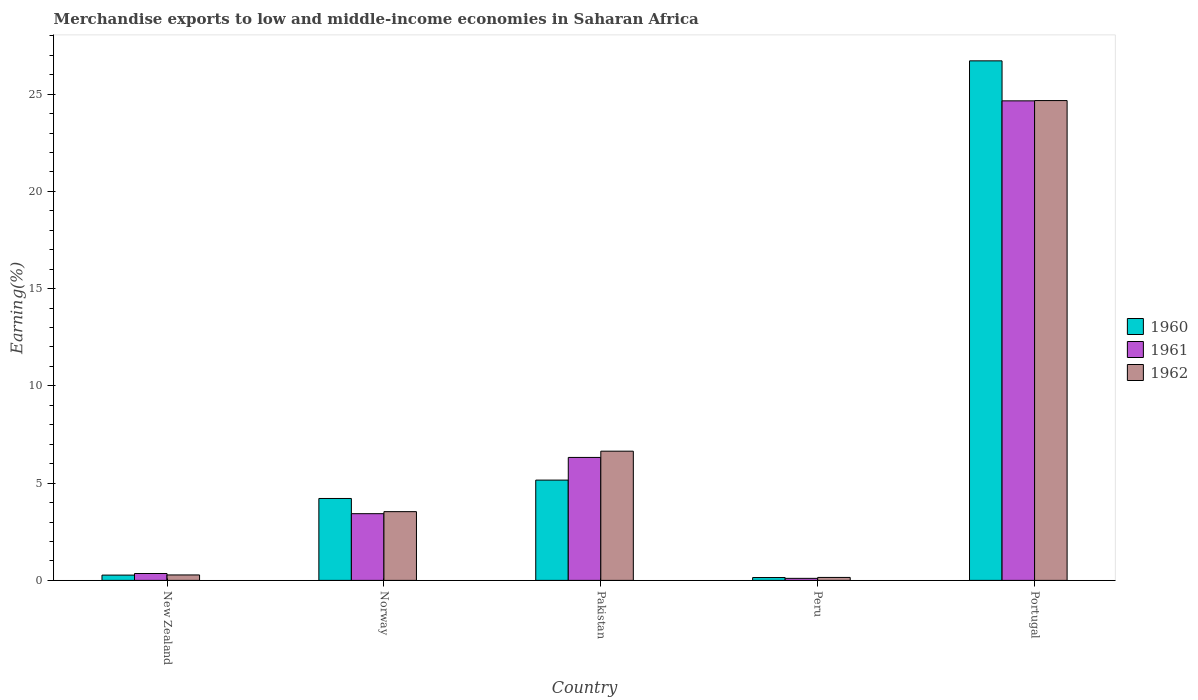Are the number of bars per tick equal to the number of legend labels?
Keep it short and to the point. Yes. Are the number of bars on each tick of the X-axis equal?
Your answer should be compact. Yes. How many bars are there on the 1st tick from the left?
Offer a very short reply. 3. How many bars are there on the 4th tick from the right?
Ensure brevity in your answer.  3. What is the percentage of amount earned from merchandise exports in 1962 in New Zealand?
Make the answer very short. 0.28. Across all countries, what is the maximum percentage of amount earned from merchandise exports in 1961?
Offer a very short reply. 24.65. Across all countries, what is the minimum percentage of amount earned from merchandise exports in 1960?
Your answer should be very brief. 0.15. In which country was the percentage of amount earned from merchandise exports in 1960 minimum?
Offer a terse response. Peru. What is the total percentage of amount earned from merchandise exports in 1961 in the graph?
Offer a very short reply. 34.86. What is the difference between the percentage of amount earned from merchandise exports in 1962 in New Zealand and that in Portugal?
Make the answer very short. -24.39. What is the difference between the percentage of amount earned from merchandise exports in 1961 in Portugal and the percentage of amount earned from merchandise exports in 1962 in New Zealand?
Provide a short and direct response. 24.37. What is the average percentage of amount earned from merchandise exports in 1960 per country?
Your answer should be compact. 7.3. What is the difference between the percentage of amount earned from merchandise exports of/in 1961 and percentage of amount earned from merchandise exports of/in 1960 in New Zealand?
Offer a very short reply. 0.08. In how many countries, is the percentage of amount earned from merchandise exports in 1962 greater than 6 %?
Keep it short and to the point. 2. What is the ratio of the percentage of amount earned from merchandise exports in 1962 in New Zealand to that in Peru?
Your answer should be compact. 1.84. Is the percentage of amount earned from merchandise exports in 1960 in Pakistan less than that in Portugal?
Your answer should be compact. Yes. What is the difference between the highest and the second highest percentage of amount earned from merchandise exports in 1960?
Make the answer very short. 22.5. What is the difference between the highest and the lowest percentage of amount earned from merchandise exports in 1960?
Offer a terse response. 26.56. In how many countries, is the percentage of amount earned from merchandise exports in 1961 greater than the average percentage of amount earned from merchandise exports in 1961 taken over all countries?
Offer a terse response. 1. What does the 2nd bar from the left in New Zealand represents?
Your response must be concise. 1961. What does the 3rd bar from the right in New Zealand represents?
Offer a terse response. 1960. Is it the case that in every country, the sum of the percentage of amount earned from merchandise exports in 1962 and percentage of amount earned from merchandise exports in 1960 is greater than the percentage of amount earned from merchandise exports in 1961?
Provide a short and direct response. Yes. How many bars are there?
Provide a succinct answer. 15. How many countries are there in the graph?
Your answer should be very brief. 5. Does the graph contain grids?
Give a very brief answer. No. How many legend labels are there?
Provide a succinct answer. 3. What is the title of the graph?
Provide a short and direct response. Merchandise exports to low and middle-income economies in Saharan Africa. What is the label or title of the Y-axis?
Provide a short and direct response. Earning(%). What is the Earning(%) in 1960 in New Zealand?
Your response must be concise. 0.27. What is the Earning(%) of 1961 in New Zealand?
Make the answer very short. 0.35. What is the Earning(%) in 1962 in New Zealand?
Give a very brief answer. 0.28. What is the Earning(%) of 1960 in Norway?
Your answer should be compact. 4.21. What is the Earning(%) of 1961 in Norway?
Ensure brevity in your answer.  3.43. What is the Earning(%) in 1962 in Norway?
Give a very brief answer. 3.53. What is the Earning(%) of 1960 in Pakistan?
Your answer should be very brief. 5.16. What is the Earning(%) in 1961 in Pakistan?
Provide a short and direct response. 6.32. What is the Earning(%) in 1962 in Pakistan?
Offer a very short reply. 6.64. What is the Earning(%) of 1960 in Peru?
Your answer should be compact. 0.15. What is the Earning(%) in 1961 in Peru?
Your response must be concise. 0.1. What is the Earning(%) in 1962 in Peru?
Your answer should be compact. 0.15. What is the Earning(%) in 1960 in Portugal?
Give a very brief answer. 26.71. What is the Earning(%) of 1961 in Portugal?
Provide a short and direct response. 24.65. What is the Earning(%) of 1962 in Portugal?
Offer a terse response. 24.67. Across all countries, what is the maximum Earning(%) in 1960?
Offer a very short reply. 26.71. Across all countries, what is the maximum Earning(%) in 1961?
Give a very brief answer. 24.65. Across all countries, what is the maximum Earning(%) of 1962?
Offer a terse response. 24.67. Across all countries, what is the minimum Earning(%) in 1960?
Your response must be concise. 0.15. Across all countries, what is the minimum Earning(%) in 1961?
Give a very brief answer. 0.1. Across all countries, what is the minimum Earning(%) of 1962?
Provide a succinct answer. 0.15. What is the total Earning(%) of 1960 in the graph?
Provide a succinct answer. 36.5. What is the total Earning(%) in 1961 in the graph?
Offer a very short reply. 34.86. What is the total Earning(%) in 1962 in the graph?
Offer a very short reply. 35.28. What is the difference between the Earning(%) of 1960 in New Zealand and that in Norway?
Ensure brevity in your answer.  -3.94. What is the difference between the Earning(%) in 1961 in New Zealand and that in Norway?
Keep it short and to the point. -3.08. What is the difference between the Earning(%) in 1962 in New Zealand and that in Norway?
Ensure brevity in your answer.  -3.25. What is the difference between the Earning(%) of 1960 in New Zealand and that in Pakistan?
Provide a succinct answer. -4.88. What is the difference between the Earning(%) of 1961 in New Zealand and that in Pakistan?
Your answer should be compact. -5.97. What is the difference between the Earning(%) in 1962 in New Zealand and that in Pakistan?
Offer a terse response. -6.36. What is the difference between the Earning(%) in 1960 in New Zealand and that in Peru?
Give a very brief answer. 0.13. What is the difference between the Earning(%) in 1961 in New Zealand and that in Peru?
Your answer should be compact. 0.25. What is the difference between the Earning(%) of 1962 in New Zealand and that in Peru?
Provide a short and direct response. 0.13. What is the difference between the Earning(%) in 1960 in New Zealand and that in Portugal?
Provide a succinct answer. -26.44. What is the difference between the Earning(%) of 1961 in New Zealand and that in Portugal?
Your response must be concise. -24.3. What is the difference between the Earning(%) of 1962 in New Zealand and that in Portugal?
Offer a terse response. -24.39. What is the difference between the Earning(%) of 1960 in Norway and that in Pakistan?
Your response must be concise. -0.94. What is the difference between the Earning(%) in 1961 in Norway and that in Pakistan?
Offer a terse response. -2.89. What is the difference between the Earning(%) of 1962 in Norway and that in Pakistan?
Give a very brief answer. -3.11. What is the difference between the Earning(%) in 1960 in Norway and that in Peru?
Offer a terse response. 4.06. What is the difference between the Earning(%) of 1961 in Norway and that in Peru?
Offer a very short reply. 3.32. What is the difference between the Earning(%) of 1962 in Norway and that in Peru?
Your answer should be very brief. 3.38. What is the difference between the Earning(%) of 1960 in Norway and that in Portugal?
Provide a succinct answer. -22.5. What is the difference between the Earning(%) in 1961 in Norway and that in Portugal?
Your response must be concise. -21.22. What is the difference between the Earning(%) in 1962 in Norway and that in Portugal?
Your answer should be very brief. -21.13. What is the difference between the Earning(%) of 1960 in Pakistan and that in Peru?
Make the answer very short. 5.01. What is the difference between the Earning(%) in 1961 in Pakistan and that in Peru?
Your answer should be compact. 6.22. What is the difference between the Earning(%) of 1962 in Pakistan and that in Peru?
Ensure brevity in your answer.  6.49. What is the difference between the Earning(%) of 1960 in Pakistan and that in Portugal?
Your answer should be very brief. -21.55. What is the difference between the Earning(%) of 1961 in Pakistan and that in Portugal?
Provide a short and direct response. -18.33. What is the difference between the Earning(%) in 1962 in Pakistan and that in Portugal?
Offer a terse response. -18.03. What is the difference between the Earning(%) of 1960 in Peru and that in Portugal?
Make the answer very short. -26.56. What is the difference between the Earning(%) of 1961 in Peru and that in Portugal?
Make the answer very short. -24.55. What is the difference between the Earning(%) of 1962 in Peru and that in Portugal?
Offer a terse response. -24.52. What is the difference between the Earning(%) in 1960 in New Zealand and the Earning(%) in 1961 in Norway?
Offer a very short reply. -3.16. What is the difference between the Earning(%) in 1960 in New Zealand and the Earning(%) in 1962 in Norway?
Your response must be concise. -3.26. What is the difference between the Earning(%) of 1961 in New Zealand and the Earning(%) of 1962 in Norway?
Provide a short and direct response. -3.18. What is the difference between the Earning(%) in 1960 in New Zealand and the Earning(%) in 1961 in Pakistan?
Offer a terse response. -6.05. What is the difference between the Earning(%) of 1960 in New Zealand and the Earning(%) of 1962 in Pakistan?
Provide a short and direct response. -6.37. What is the difference between the Earning(%) of 1961 in New Zealand and the Earning(%) of 1962 in Pakistan?
Make the answer very short. -6.29. What is the difference between the Earning(%) in 1960 in New Zealand and the Earning(%) in 1961 in Peru?
Keep it short and to the point. 0.17. What is the difference between the Earning(%) of 1960 in New Zealand and the Earning(%) of 1962 in Peru?
Offer a very short reply. 0.12. What is the difference between the Earning(%) of 1961 in New Zealand and the Earning(%) of 1962 in Peru?
Offer a terse response. 0.2. What is the difference between the Earning(%) of 1960 in New Zealand and the Earning(%) of 1961 in Portugal?
Ensure brevity in your answer.  -24.38. What is the difference between the Earning(%) of 1960 in New Zealand and the Earning(%) of 1962 in Portugal?
Offer a terse response. -24.4. What is the difference between the Earning(%) in 1961 in New Zealand and the Earning(%) in 1962 in Portugal?
Provide a succinct answer. -24.31. What is the difference between the Earning(%) of 1960 in Norway and the Earning(%) of 1961 in Pakistan?
Offer a very short reply. -2.11. What is the difference between the Earning(%) in 1960 in Norway and the Earning(%) in 1962 in Pakistan?
Provide a short and direct response. -2.43. What is the difference between the Earning(%) of 1961 in Norway and the Earning(%) of 1962 in Pakistan?
Your response must be concise. -3.21. What is the difference between the Earning(%) of 1960 in Norway and the Earning(%) of 1961 in Peru?
Your response must be concise. 4.11. What is the difference between the Earning(%) of 1960 in Norway and the Earning(%) of 1962 in Peru?
Give a very brief answer. 4.06. What is the difference between the Earning(%) of 1961 in Norway and the Earning(%) of 1962 in Peru?
Ensure brevity in your answer.  3.28. What is the difference between the Earning(%) in 1960 in Norway and the Earning(%) in 1961 in Portugal?
Keep it short and to the point. -20.44. What is the difference between the Earning(%) in 1960 in Norway and the Earning(%) in 1962 in Portugal?
Offer a terse response. -20.46. What is the difference between the Earning(%) in 1961 in Norway and the Earning(%) in 1962 in Portugal?
Keep it short and to the point. -21.24. What is the difference between the Earning(%) of 1960 in Pakistan and the Earning(%) of 1961 in Peru?
Keep it short and to the point. 5.05. What is the difference between the Earning(%) of 1960 in Pakistan and the Earning(%) of 1962 in Peru?
Provide a succinct answer. 5. What is the difference between the Earning(%) of 1961 in Pakistan and the Earning(%) of 1962 in Peru?
Provide a succinct answer. 6.17. What is the difference between the Earning(%) of 1960 in Pakistan and the Earning(%) of 1961 in Portugal?
Give a very brief answer. -19.5. What is the difference between the Earning(%) in 1960 in Pakistan and the Earning(%) in 1962 in Portugal?
Provide a short and direct response. -19.51. What is the difference between the Earning(%) in 1961 in Pakistan and the Earning(%) in 1962 in Portugal?
Keep it short and to the point. -18.35. What is the difference between the Earning(%) in 1960 in Peru and the Earning(%) in 1961 in Portugal?
Ensure brevity in your answer.  -24.51. What is the difference between the Earning(%) of 1960 in Peru and the Earning(%) of 1962 in Portugal?
Provide a short and direct response. -24.52. What is the difference between the Earning(%) of 1961 in Peru and the Earning(%) of 1962 in Portugal?
Make the answer very short. -24.56. What is the average Earning(%) of 1960 per country?
Your response must be concise. 7.3. What is the average Earning(%) in 1961 per country?
Provide a succinct answer. 6.97. What is the average Earning(%) in 1962 per country?
Your response must be concise. 7.06. What is the difference between the Earning(%) of 1960 and Earning(%) of 1961 in New Zealand?
Offer a very short reply. -0.08. What is the difference between the Earning(%) in 1960 and Earning(%) in 1962 in New Zealand?
Give a very brief answer. -0.01. What is the difference between the Earning(%) of 1961 and Earning(%) of 1962 in New Zealand?
Offer a very short reply. 0.07. What is the difference between the Earning(%) in 1960 and Earning(%) in 1961 in Norway?
Your answer should be very brief. 0.78. What is the difference between the Earning(%) of 1960 and Earning(%) of 1962 in Norway?
Give a very brief answer. 0.68. What is the difference between the Earning(%) of 1961 and Earning(%) of 1962 in Norway?
Your answer should be compact. -0.1. What is the difference between the Earning(%) in 1960 and Earning(%) in 1961 in Pakistan?
Offer a terse response. -1.17. What is the difference between the Earning(%) in 1960 and Earning(%) in 1962 in Pakistan?
Provide a short and direct response. -1.49. What is the difference between the Earning(%) of 1961 and Earning(%) of 1962 in Pakistan?
Make the answer very short. -0.32. What is the difference between the Earning(%) of 1960 and Earning(%) of 1961 in Peru?
Provide a short and direct response. 0.04. What is the difference between the Earning(%) in 1960 and Earning(%) in 1962 in Peru?
Offer a very short reply. -0.01. What is the difference between the Earning(%) in 1961 and Earning(%) in 1962 in Peru?
Give a very brief answer. -0.05. What is the difference between the Earning(%) of 1960 and Earning(%) of 1961 in Portugal?
Provide a succinct answer. 2.06. What is the difference between the Earning(%) in 1960 and Earning(%) in 1962 in Portugal?
Offer a terse response. 2.04. What is the difference between the Earning(%) of 1961 and Earning(%) of 1962 in Portugal?
Ensure brevity in your answer.  -0.01. What is the ratio of the Earning(%) of 1960 in New Zealand to that in Norway?
Make the answer very short. 0.06. What is the ratio of the Earning(%) of 1961 in New Zealand to that in Norway?
Your answer should be very brief. 0.1. What is the ratio of the Earning(%) of 1962 in New Zealand to that in Norway?
Ensure brevity in your answer.  0.08. What is the ratio of the Earning(%) of 1960 in New Zealand to that in Pakistan?
Keep it short and to the point. 0.05. What is the ratio of the Earning(%) of 1961 in New Zealand to that in Pakistan?
Your response must be concise. 0.06. What is the ratio of the Earning(%) in 1962 in New Zealand to that in Pakistan?
Give a very brief answer. 0.04. What is the ratio of the Earning(%) of 1960 in New Zealand to that in Peru?
Make the answer very short. 1.85. What is the ratio of the Earning(%) of 1961 in New Zealand to that in Peru?
Your response must be concise. 3.37. What is the ratio of the Earning(%) of 1962 in New Zealand to that in Peru?
Your response must be concise. 1.84. What is the ratio of the Earning(%) in 1960 in New Zealand to that in Portugal?
Your answer should be compact. 0.01. What is the ratio of the Earning(%) of 1961 in New Zealand to that in Portugal?
Ensure brevity in your answer.  0.01. What is the ratio of the Earning(%) of 1962 in New Zealand to that in Portugal?
Your answer should be very brief. 0.01. What is the ratio of the Earning(%) of 1960 in Norway to that in Pakistan?
Keep it short and to the point. 0.82. What is the ratio of the Earning(%) of 1961 in Norway to that in Pakistan?
Provide a short and direct response. 0.54. What is the ratio of the Earning(%) in 1962 in Norway to that in Pakistan?
Your answer should be very brief. 0.53. What is the ratio of the Earning(%) in 1960 in Norway to that in Peru?
Make the answer very short. 28.69. What is the ratio of the Earning(%) of 1961 in Norway to that in Peru?
Offer a very short reply. 32.67. What is the ratio of the Earning(%) in 1962 in Norway to that in Peru?
Provide a succinct answer. 23.23. What is the ratio of the Earning(%) of 1960 in Norway to that in Portugal?
Offer a terse response. 0.16. What is the ratio of the Earning(%) of 1961 in Norway to that in Portugal?
Make the answer very short. 0.14. What is the ratio of the Earning(%) of 1962 in Norway to that in Portugal?
Provide a short and direct response. 0.14. What is the ratio of the Earning(%) in 1960 in Pakistan to that in Peru?
Your answer should be compact. 35.13. What is the ratio of the Earning(%) of 1961 in Pakistan to that in Peru?
Keep it short and to the point. 60.22. What is the ratio of the Earning(%) of 1962 in Pakistan to that in Peru?
Offer a very short reply. 43.66. What is the ratio of the Earning(%) of 1960 in Pakistan to that in Portugal?
Ensure brevity in your answer.  0.19. What is the ratio of the Earning(%) of 1961 in Pakistan to that in Portugal?
Give a very brief answer. 0.26. What is the ratio of the Earning(%) of 1962 in Pakistan to that in Portugal?
Give a very brief answer. 0.27. What is the ratio of the Earning(%) in 1960 in Peru to that in Portugal?
Make the answer very short. 0.01. What is the ratio of the Earning(%) in 1961 in Peru to that in Portugal?
Provide a short and direct response. 0. What is the ratio of the Earning(%) in 1962 in Peru to that in Portugal?
Your response must be concise. 0.01. What is the difference between the highest and the second highest Earning(%) in 1960?
Your answer should be very brief. 21.55. What is the difference between the highest and the second highest Earning(%) of 1961?
Offer a very short reply. 18.33. What is the difference between the highest and the second highest Earning(%) of 1962?
Provide a succinct answer. 18.03. What is the difference between the highest and the lowest Earning(%) in 1960?
Offer a terse response. 26.56. What is the difference between the highest and the lowest Earning(%) of 1961?
Your response must be concise. 24.55. What is the difference between the highest and the lowest Earning(%) of 1962?
Provide a short and direct response. 24.52. 